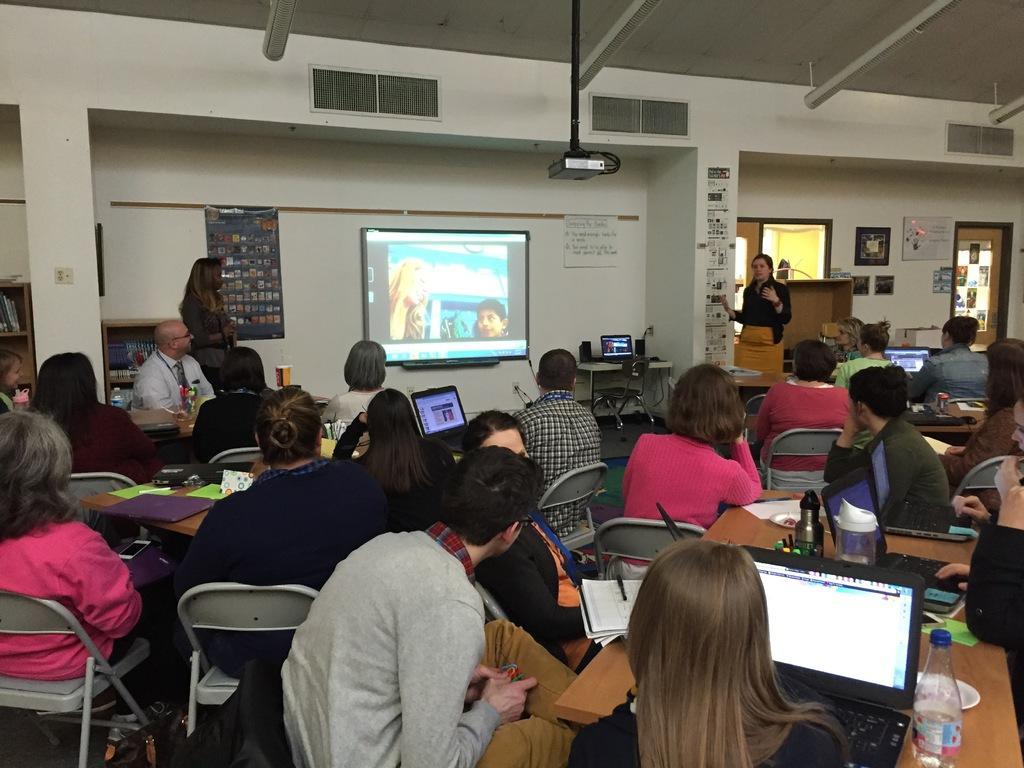In one or two sentences, can you explain what this image depicts? As we can see in the image there is a white color wall, banner, screen, projector and few people siting on chairs and there are tables. On table there are laptops and books. 